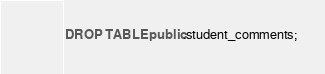Convert code to text. <code><loc_0><loc_0><loc_500><loc_500><_SQL_>DROP TABLE public.student_comments;</code> 